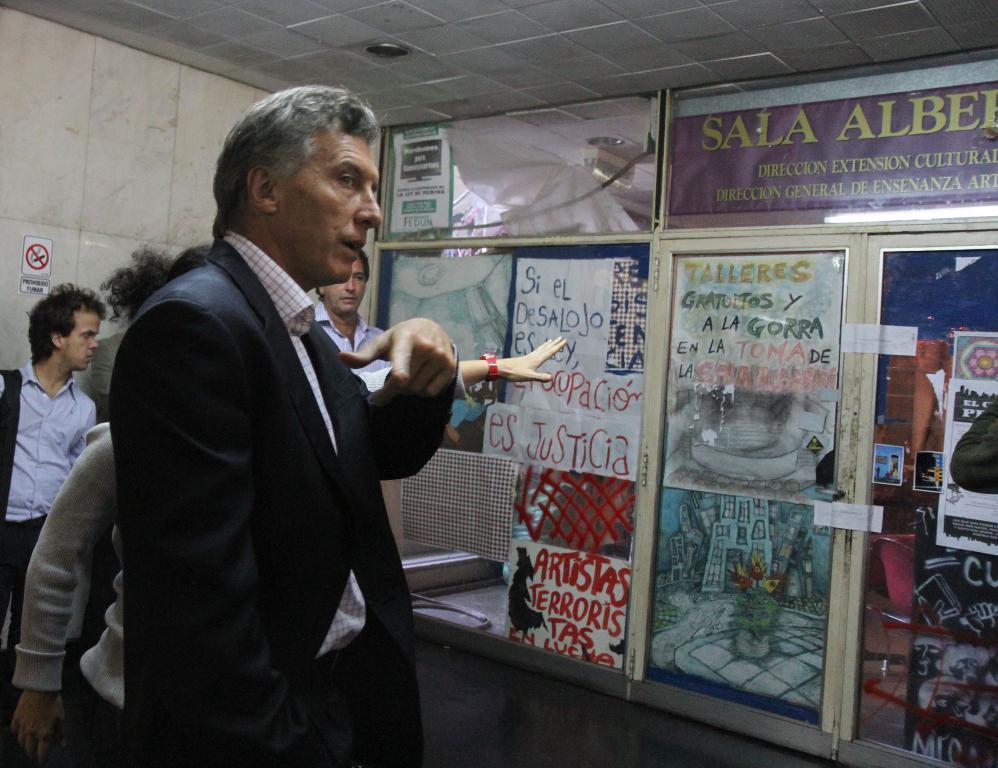Can you describe this image briefly? In this image we can see people and there are posters pasted on the walls. In the background there is a wall and we can see a door. 